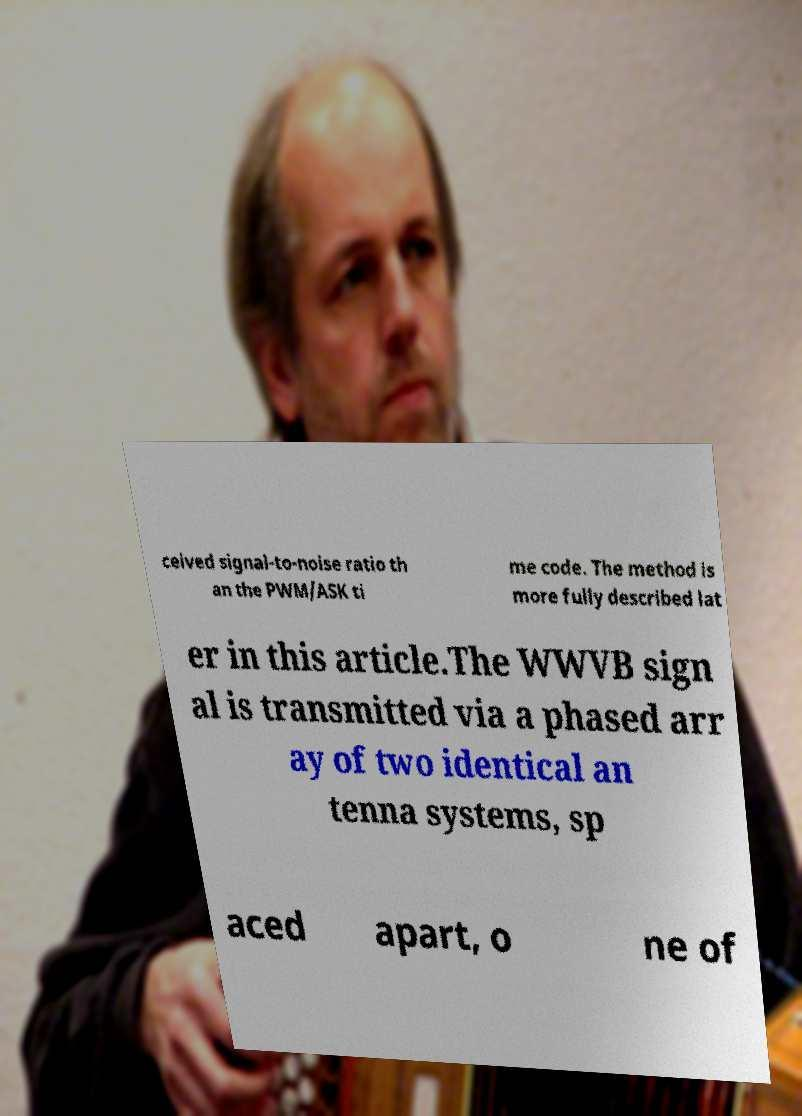Please read and relay the text visible in this image. What does it say? ceived signal-to-noise ratio th an the PWM/ASK ti me code. The method is more fully described lat er in this article.The WWVB sign al is transmitted via a phased arr ay of two identical an tenna systems, sp aced apart, o ne of 